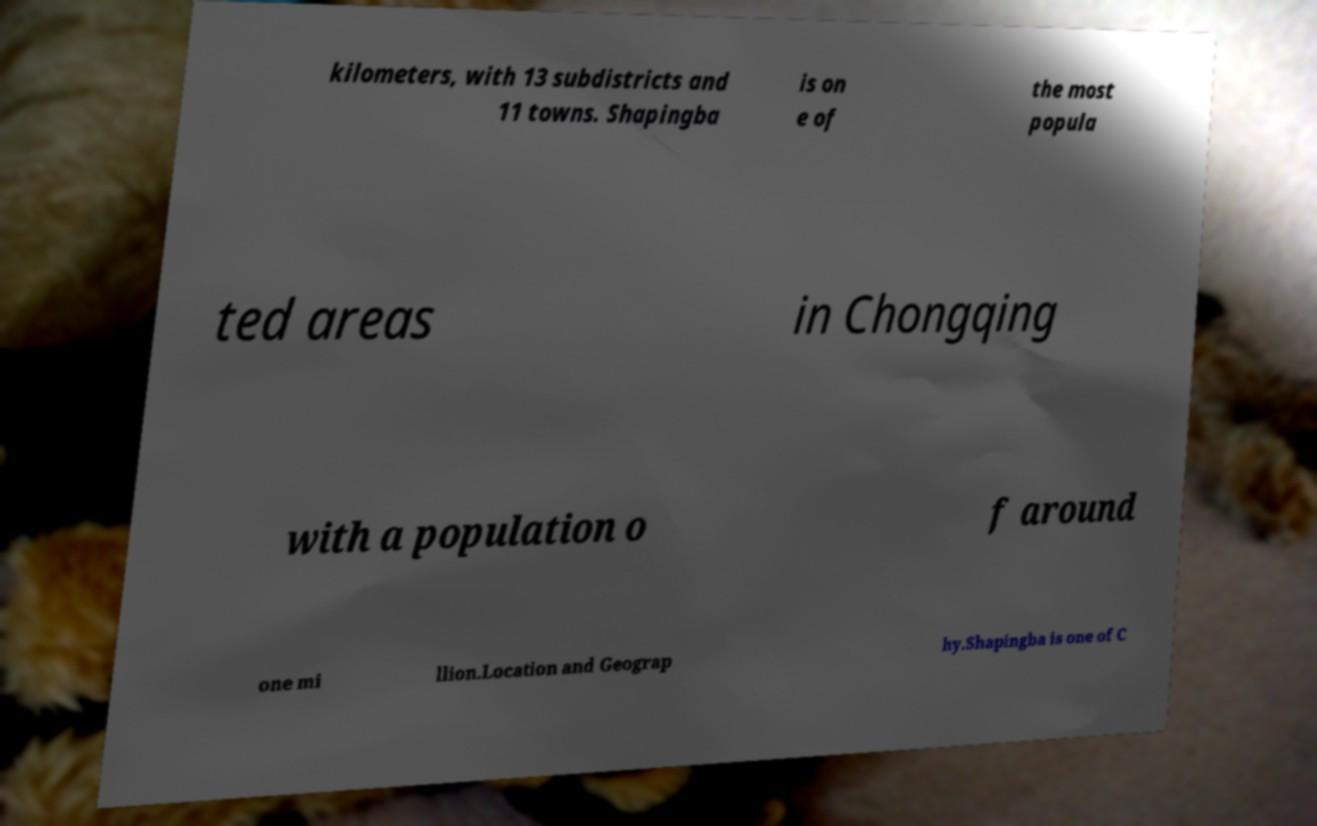Please identify and transcribe the text found in this image. kilometers, with 13 subdistricts and 11 towns. Shapingba is on e of the most popula ted areas in Chongqing with a population o f around one mi llion.Location and Geograp hy.Shapingba is one of C 